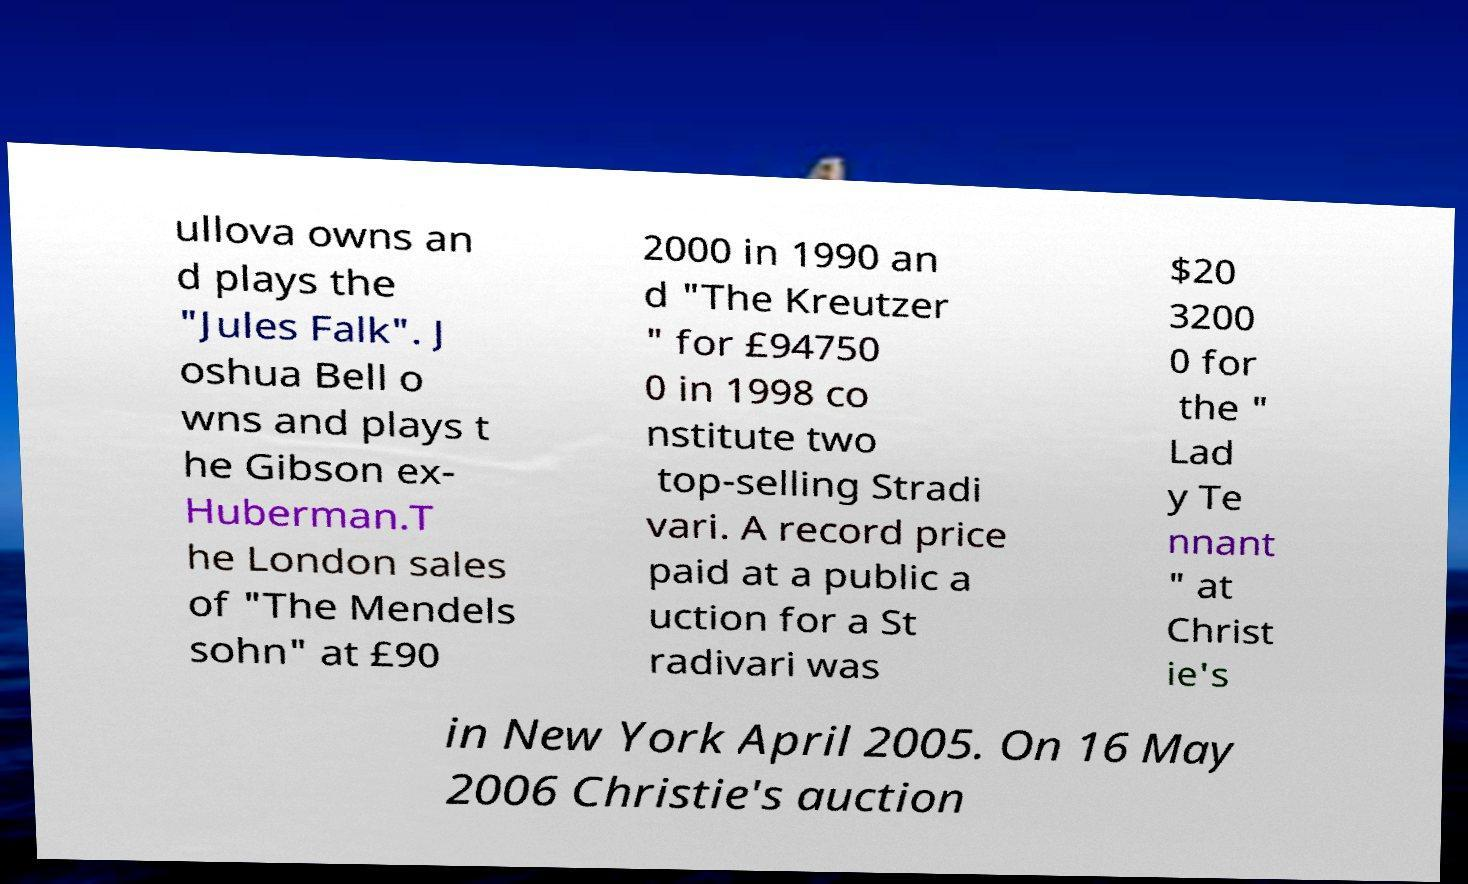Please identify and transcribe the text found in this image. ullova owns an d plays the "Jules Falk". J oshua Bell o wns and plays t he Gibson ex- Huberman.T he London sales of "The Mendels sohn" at £90 2000 in 1990 an d "The Kreutzer " for £94750 0 in 1998 co nstitute two top-selling Stradi vari. A record price paid at a public a uction for a St radivari was $20 3200 0 for the " Lad y Te nnant " at Christ ie's in New York April 2005. On 16 May 2006 Christie's auction 